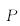<formula> <loc_0><loc_0><loc_500><loc_500>P</formula> 